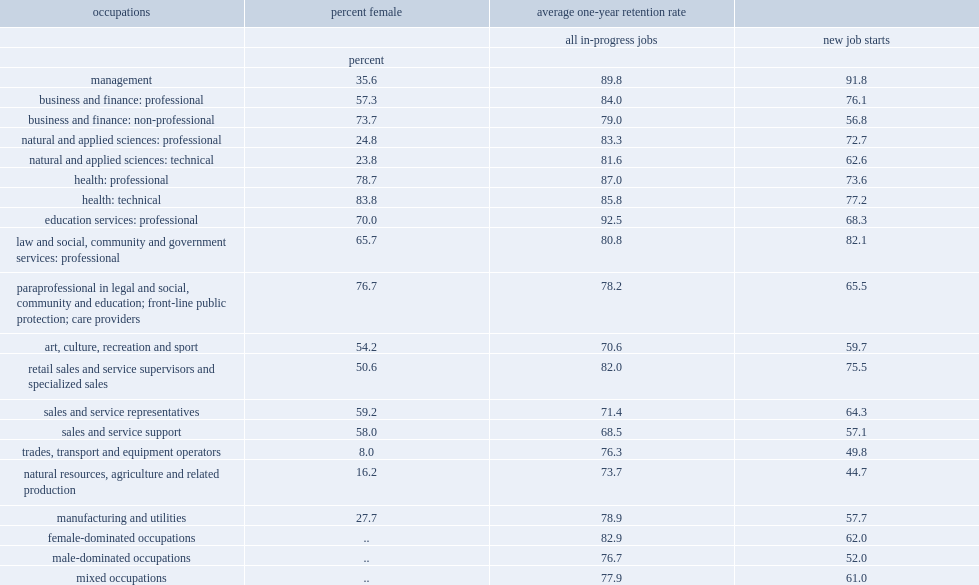How many percent of female-dominated occupations-defined as occupations where the proportion of female workers? 82.9. How many percent of male-dominated occupations-defined as occupations where the proportion of male workers? 76.7. How many percent of examining detailed occupations, female-dominated occupations in health have higher levels of job stability than those in trades, transport and equipment operators largely dominated by men? 87.0. How many percent of examining detailed occupations, female-dominated occupations in education professions have higher levels of job stability than those in trades, transport and equipment operators largely dominated by men? 92.5. When men are employed in female-dominated occupations, what is their average one-year retention rate? 82.9. 